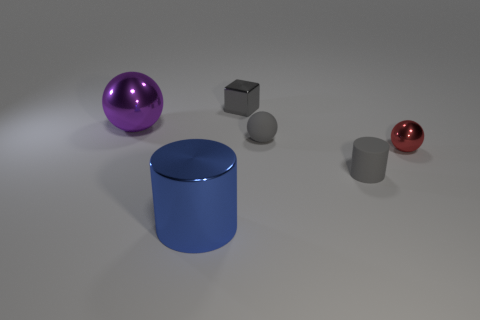Subtract all small balls. How many balls are left? 1 Add 4 large gray objects. How many objects exist? 10 Subtract all gray cylinders. How many cylinders are left? 1 Subtract 1 spheres. How many spheres are left? 2 Subtract all cylinders. How many objects are left? 4 Add 2 small gray matte objects. How many small gray matte objects are left? 4 Add 3 tiny gray blocks. How many tiny gray blocks exist? 4 Subtract 1 purple spheres. How many objects are left? 5 Subtract all red cubes. Subtract all blue cylinders. How many cubes are left? 1 Subtract all tiny shiny blocks. Subtract all big gray rubber objects. How many objects are left? 5 